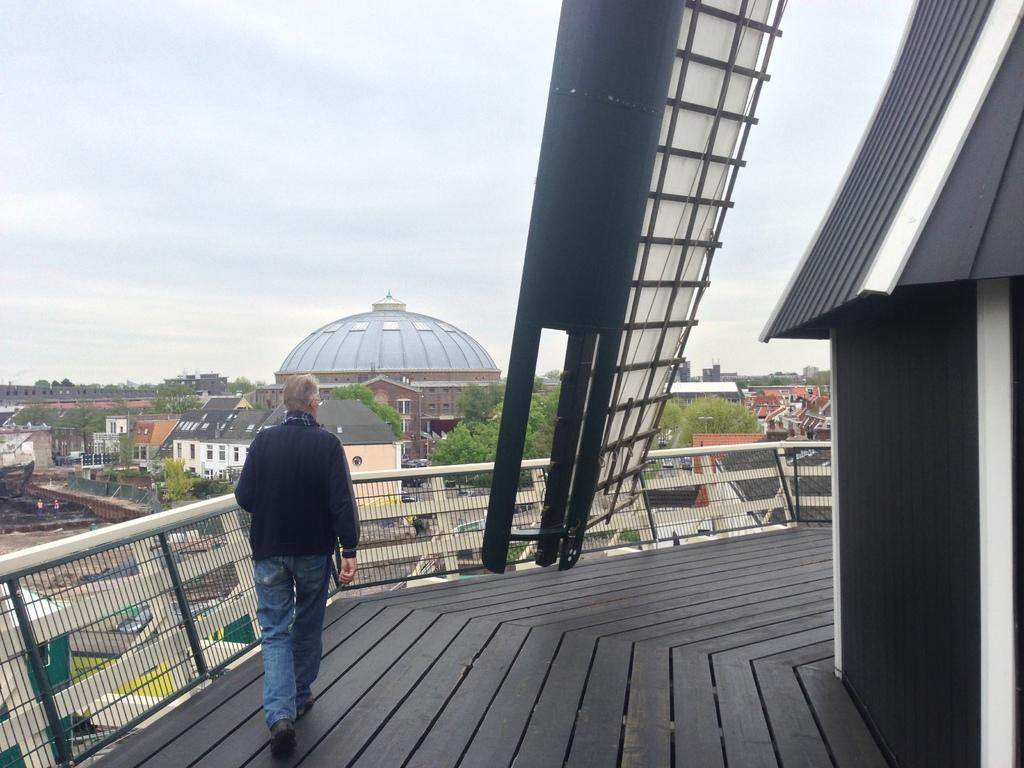What is the person in the image doing? The person is walking in the image. On what surface is the person walking? The person is walking on a surface. What can be seen in the image besides the person walking? There is a fence, buildings, trees, and some objects in the image. What is visible in the background of the image? The sky is visible in the background of the image. What type of bells can be heard ringing in the image? There are no bells present in the image, and therefore no sound can be heard. 